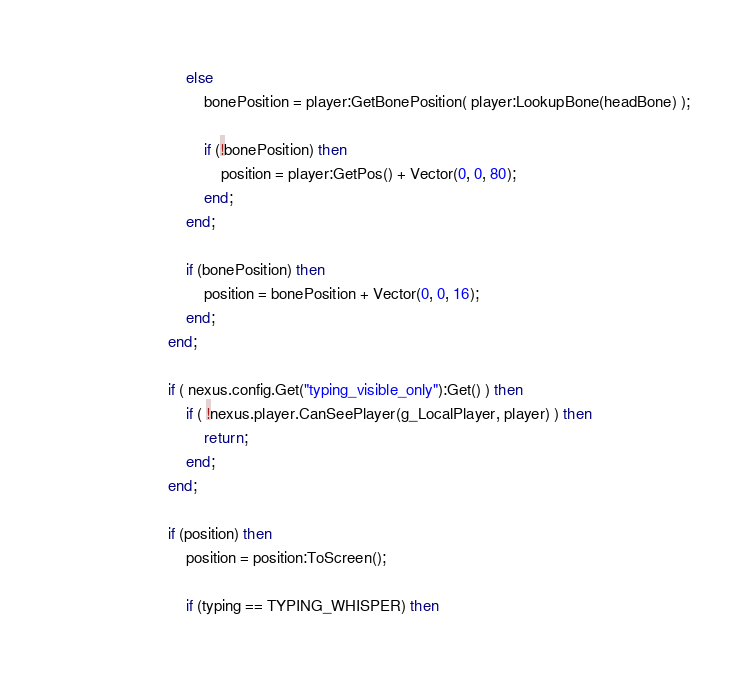<code> <loc_0><loc_0><loc_500><loc_500><_Lua_>							else
								bonePosition = player:GetBonePosition( player:LookupBone(headBone) );
								
								if (!bonePosition) then
									position = player:GetPos() + Vector(0, 0, 80);
								end;
							end;
							
							if (bonePosition) then
								position = bonePosition + Vector(0, 0, 16);
							end;
						end;
						
						if ( nexus.config.Get("typing_visible_only"):Get() ) then
							if ( !nexus.player.CanSeePlayer(g_LocalPlayer, player) ) then
								return;
							end;
						end;
						
						if (position) then
							position = position:ToScreen();
							
							if (typing == TYPING_WHISPER) then</code> 